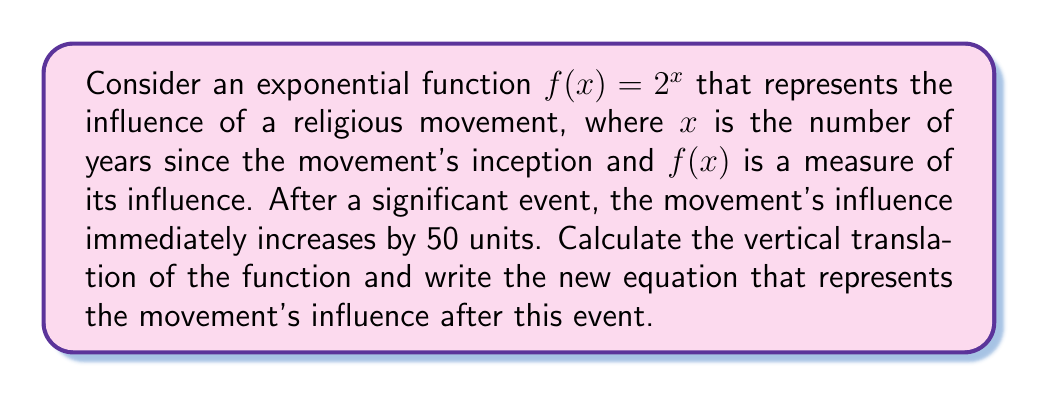Can you answer this question? To solve this problem, we need to understand vertical translations of functions:

1) A vertical translation of a function $f(x)$ by $k$ units upward is represented by $f(x) + k$.

2) In this case, the original function is $f(x) = 2^x$.

3) The influence increases by 50 units, which means we need to shift the function up by 50 units.

4) Therefore, the new function will be $g(x) = f(x) + 50$.

5) Substituting the original function, we get:
   $g(x) = 2^x + 50$

This new function $g(x)$ represents the movement's influence after the significant event. At any given $x$ (number of years), the influence will be 50 units higher than it would have been before the event.

The vertical translation is upward by 50 units.
Answer: The vertical translation is 50 units upward.
The new equation is $g(x) = 2^x + 50$. 